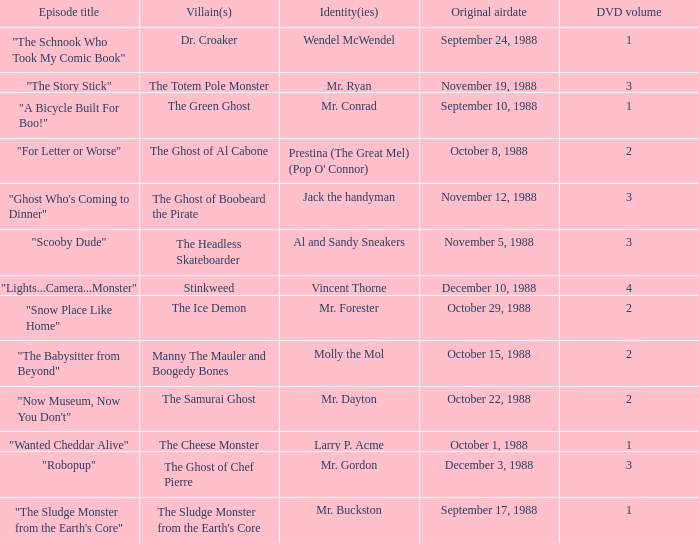Name the episode that aired october 8, 1988 "For Letter or Worse". 